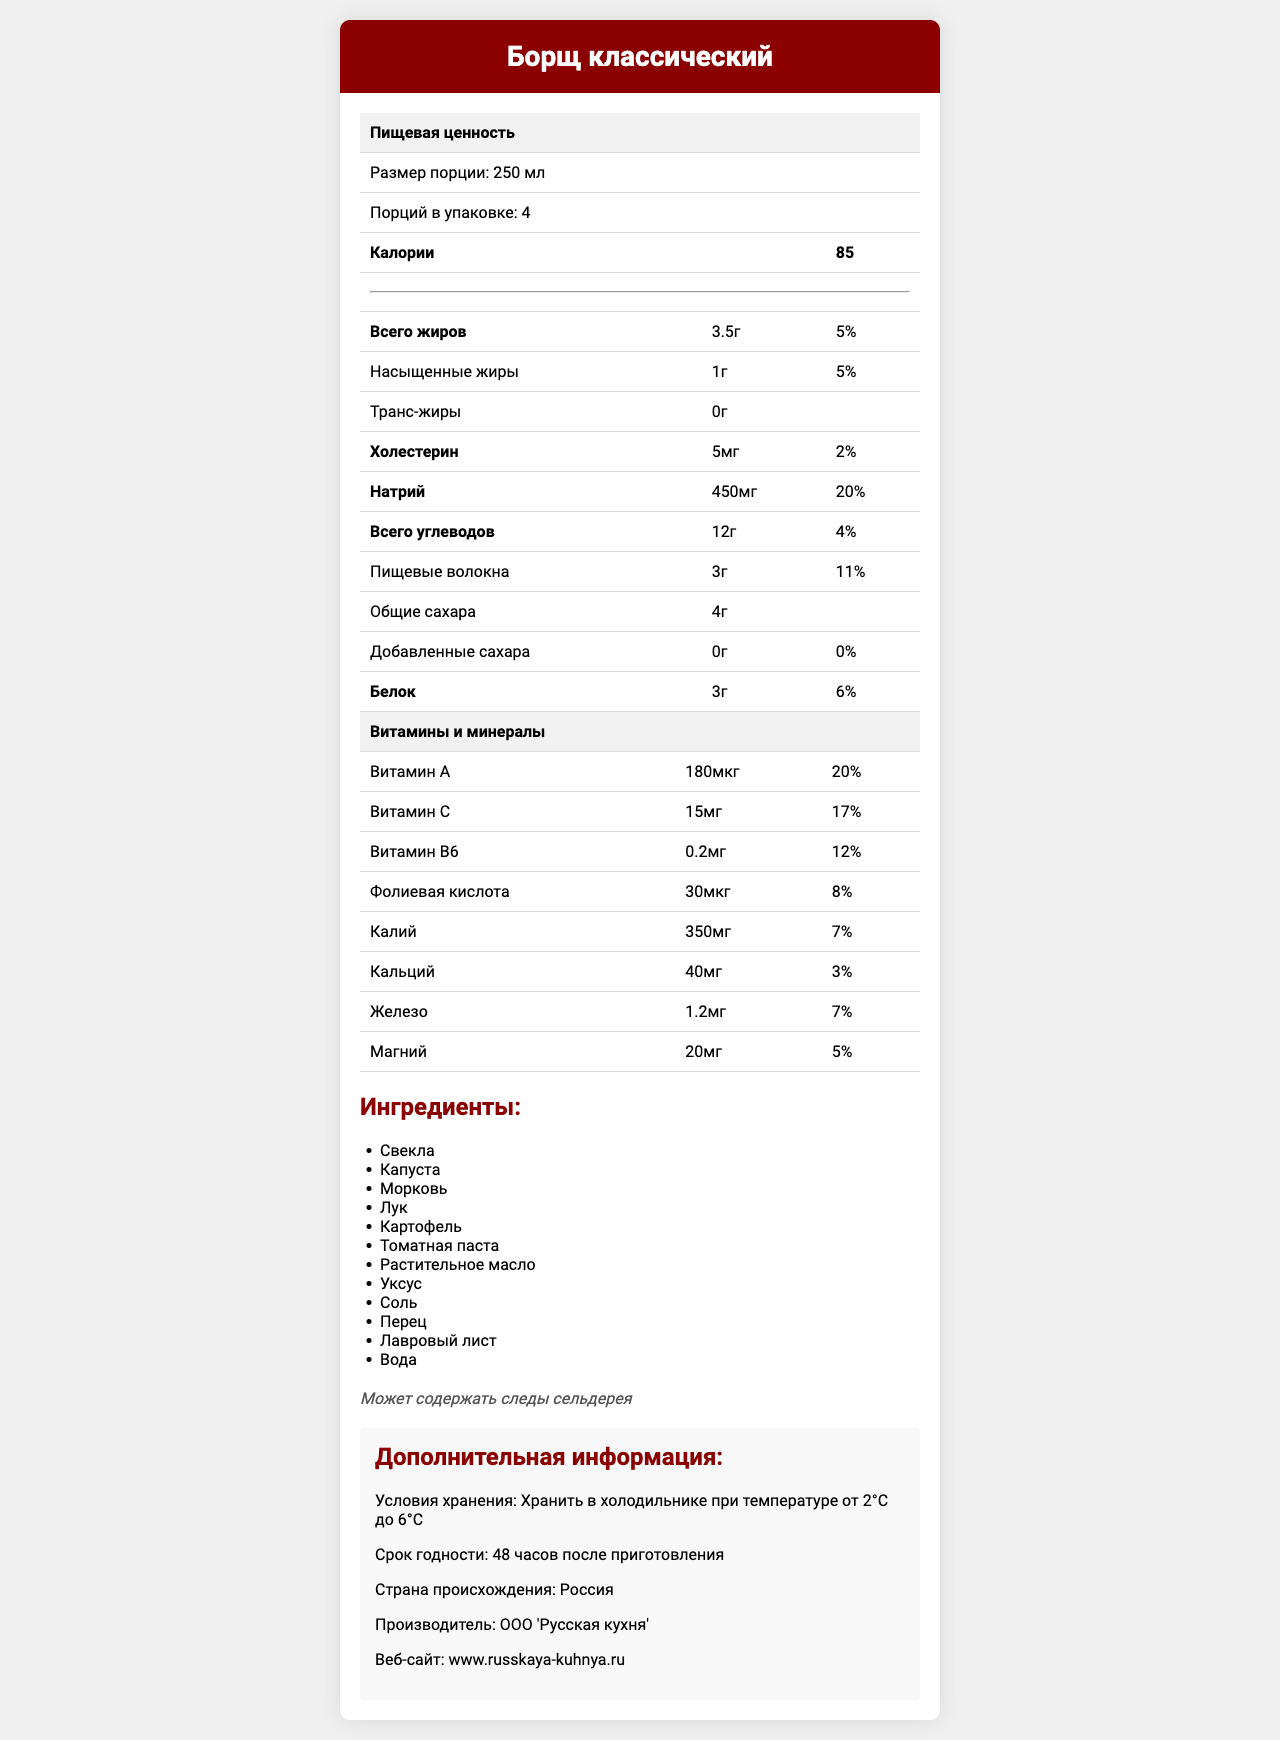what is the serving size of Борщ классический? The serving size is clearly indicated as "Размер порции: 250 мл" in the document.
Answer: 250 мл how many servings are there in one container? The document states "Порций в упаковке: 4", indicating that there are 4 servings per container.
Answer: 4 how many calories are in each serving? The document lists "Калории" as 85 per serving.
Answer: 85 what is the amount of total fat per serving? The document indicates "Всего жиров" as 3.5 г per serving.
Answer: 3.5 г what is the percentage of the daily value of protein in one serving? The "Белок" entry shows a daily value of 6%.
Answer: 6% which vitamin has the highest daily value percentage per serving? A. Витамин A B. Витамин C C. Витамин B6 D. Фолиевая кислота Витамин A has a daily value of 20%, which is higher than Витамин C (17%), Витамин B6 (12%), and Фолиевая кислота (8%).
Answer: A how much sodium does one serving contain? A. 350 мг B. 450 мг C. 500 мг D. 600 мг One serving contains 450 мг of sodium, as indicated by "Натрий".
Answer: B does this Борщ contain any trans fats? The document states "Транс-жиры: 0 г", indicating there are no trans fats.
Answer: No is it true that Борщ contains added sugars? The document lists "Добавленные сахара: 0 г", indicating there are no added sugars.
Answer: False summarize the nutritional content and additional information of Борщ классический. The document provides detailed nutritional information, ingredient list, storage instructions, and manufacturer details for Борщ классический.
Answer: Борщ классический contains 85 calories per 250 мл serving, with a mix of fats, carbohydrates, and proteins, along with various vitamins and minerals. It should be refrigerated and consumed within 48 hours of cooking. The ingredients include vegetables like свекла, капуста, and морковь, and it may contain traces of сельдерея. Manufactured in Russia by ООО 'Русская кухня'. what is the manufacturer’s contact number? The document does not provide the manufacturer's contact number, only the name and website of the manufacturer.
Answer: Not enough information 